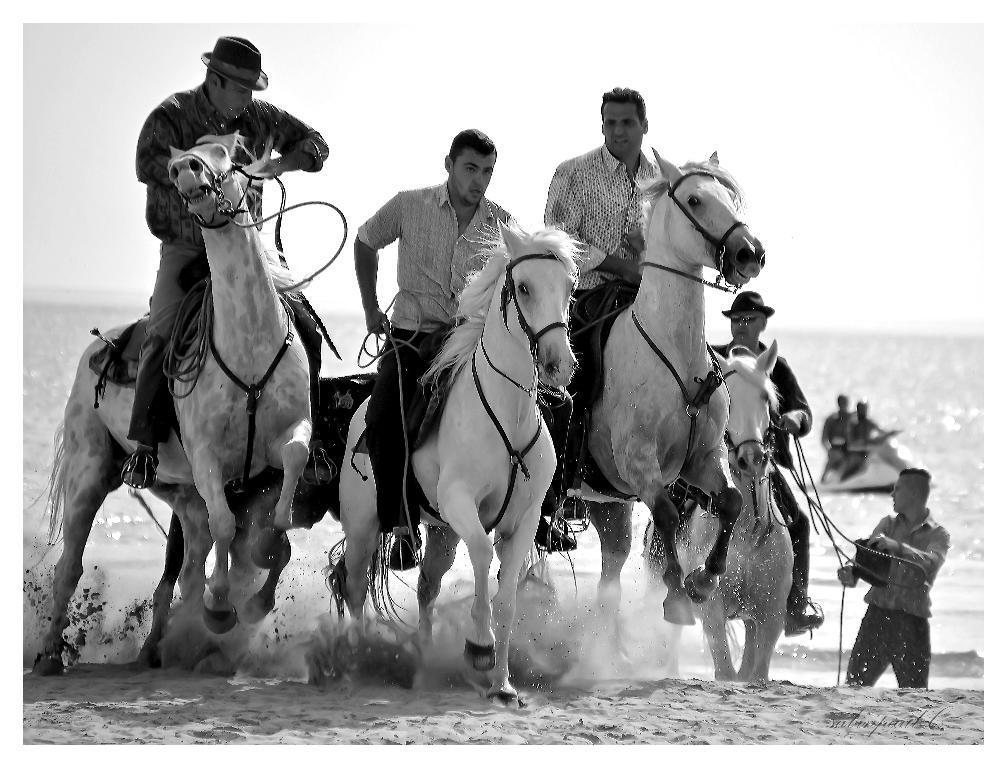Describe this image in one or two sentences. In this picture we can see some persons sitting on horses and riding and in background we can see two persons on water bike here we can see water. 